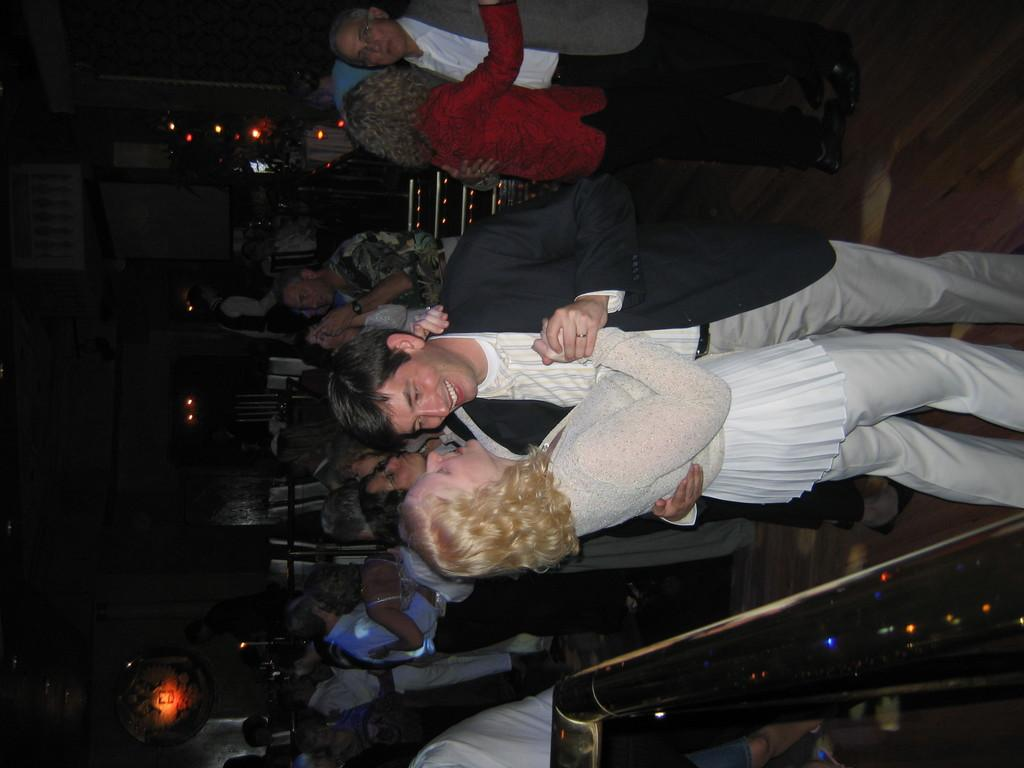What type of setting is depicted in the image? The image appears to depict a club setting. What are the people in the image doing? There are couples dancing in the image. Can you describe the background of the image? There are two people and lights visible in the background of the image. What type of knot is being tied by the people in the image? There is no knot-tying activity depicted in the image; the people are dancing. What invention is being used by the people in the image? There is no specific invention mentioned or depicted in the image; it shows a club setting with people dancing. 